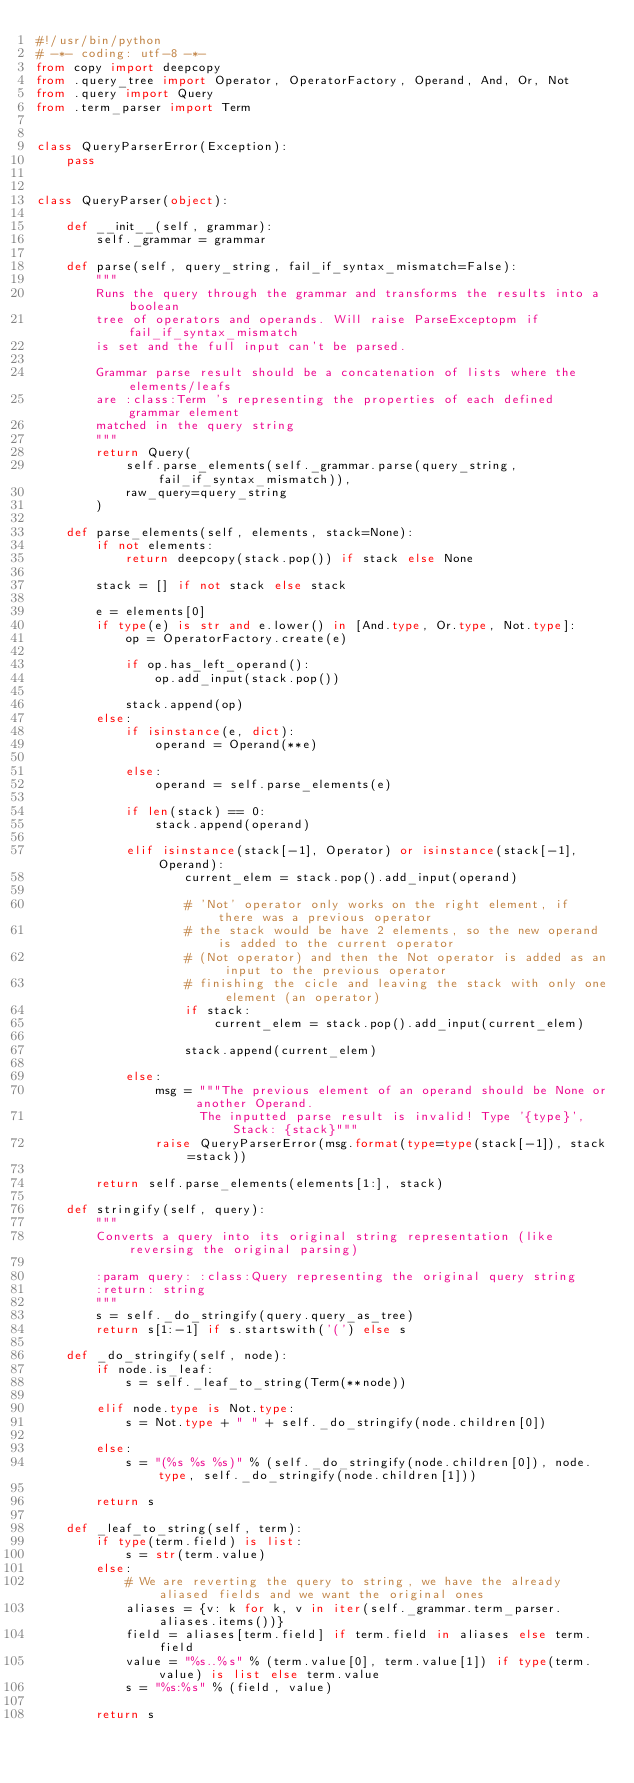<code> <loc_0><loc_0><loc_500><loc_500><_Python_>#!/usr/bin/python
# -*- coding: utf-8 -*-
from copy import deepcopy
from .query_tree import Operator, OperatorFactory, Operand, And, Or, Not
from .query import Query
from .term_parser import Term


class QueryParserError(Exception):
    pass


class QueryParser(object):

    def __init__(self, grammar):
        self._grammar = grammar

    def parse(self, query_string, fail_if_syntax_mismatch=False):
        """
        Runs the query through the grammar and transforms the results into a boolean
        tree of operators and operands. Will raise ParseExceptopm if fail_if_syntax_mismatch
        is set and the full input can't be parsed.

        Grammar parse result should be a concatenation of lists where the elements/leafs
        are :class:Term 's representing the properties of each defined grammar element
        matched in the query string
        """
        return Query(
            self.parse_elements(self._grammar.parse(query_string, fail_if_syntax_mismatch)),
            raw_query=query_string
        )

    def parse_elements(self, elements, stack=None):
        if not elements:
            return deepcopy(stack.pop()) if stack else None

        stack = [] if not stack else stack

        e = elements[0]
        if type(e) is str and e.lower() in [And.type, Or.type, Not.type]:
            op = OperatorFactory.create(e)

            if op.has_left_operand():
                op.add_input(stack.pop())

            stack.append(op)
        else:
            if isinstance(e, dict):
                operand = Operand(**e)

            else:
                operand = self.parse_elements(e)

            if len(stack) == 0:
                stack.append(operand)

            elif isinstance(stack[-1], Operator) or isinstance(stack[-1], Operand):
                    current_elem = stack.pop().add_input(operand)

                    # 'Not' operator only works on the right element, if there was a previous operator
                    # the stack would be have 2 elements, so the new operand is added to the current operator
                    # (Not operator) and then the Not operator is added as an input to the previous operator
                    # finishing the cicle and leaving the stack with only one element (an operator)
                    if stack:
                        current_elem = stack.pop().add_input(current_elem)

                    stack.append(current_elem)

            else:
                msg = """The previous element of an operand should be None or another Operand.
                      The inputted parse result is invalid! Type '{type}', Stack: {stack}"""
                raise QueryParserError(msg.format(type=type(stack[-1]), stack=stack))

        return self.parse_elements(elements[1:], stack)

    def stringify(self, query):
        """
        Converts a query into its original string representation (like reversing the original parsing)

        :param query: :class:Query representing the original query string
        :return: string
        """
        s = self._do_stringify(query.query_as_tree)
        return s[1:-1] if s.startswith('(') else s

    def _do_stringify(self, node):
        if node.is_leaf:
            s = self._leaf_to_string(Term(**node))

        elif node.type is Not.type:
            s = Not.type + " " + self._do_stringify(node.children[0])

        else:
            s = "(%s %s %s)" % (self._do_stringify(node.children[0]), node.type, self._do_stringify(node.children[1]))

        return s

    def _leaf_to_string(self, term):
        if type(term.field) is list:
            s = str(term.value)
        else:
            # We are reverting the query to string, we have the already aliased fields and we want the original ones
            aliases = {v: k for k, v in iter(self._grammar.term_parser.aliases.items())}
            field = aliases[term.field] if term.field in aliases else term.field
            value = "%s..%s" % (term.value[0], term.value[1]) if type(term.value) is list else term.value
            s = "%s:%s" % (field, value)

        return s
</code> 